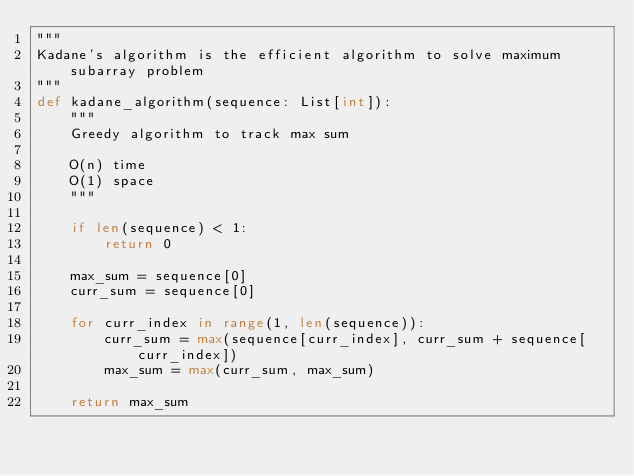Convert code to text. <code><loc_0><loc_0><loc_500><loc_500><_Python_>"""
Kadane's algorithm is the efficient algorithm to solve maximum subarray problem
"""
def kadane_algorithm(sequence: List[int]):
    """
    Greedy algorithm to track max sum 

    O(n) time 
    O(1) space
    """

    if len(sequence) < 1:
        return 0

    max_sum = sequence[0]
    curr_sum = sequence[0]

    for curr_index in range(1, len(sequence)):
        curr_sum = max(sequence[curr_index], curr_sum + sequence[curr_index])
        max_sum = max(curr_sum, max_sum)

    return max_sum

</code> 